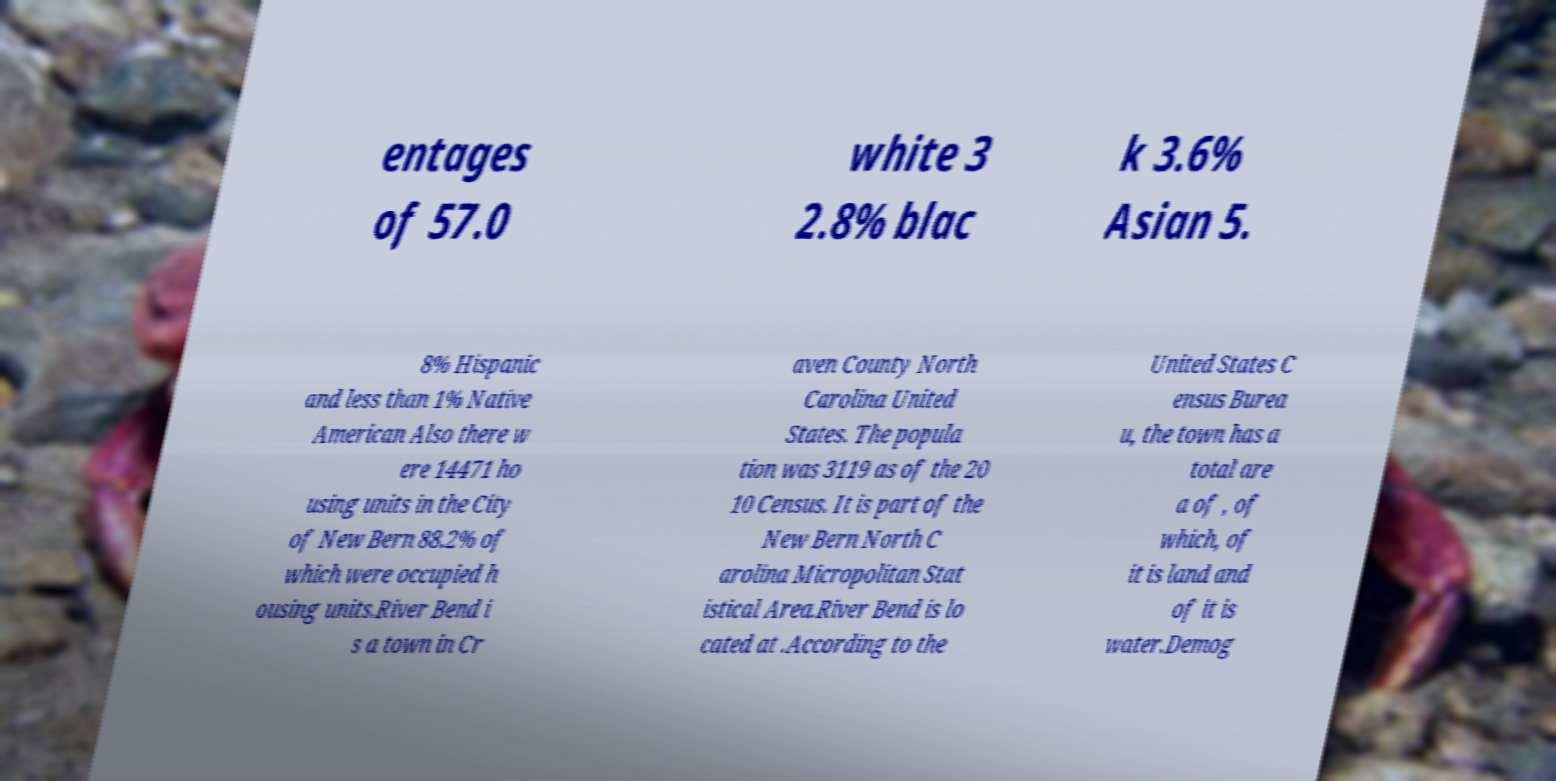There's text embedded in this image that I need extracted. Can you transcribe it verbatim? entages of 57.0 white 3 2.8% blac k 3.6% Asian 5. 8% Hispanic and less than 1% Native American Also there w ere 14471 ho using units in the City of New Bern 88.2% of which were occupied h ousing units.River Bend i s a town in Cr aven County North Carolina United States. The popula tion was 3119 as of the 20 10 Census. It is part of the New Bern North C arolina Micropolitan Stat istical Area.River Bend is lo cated at .According to the United States C ensus Burea u, the town has a total are a of , of which, of it is land and of it is water.Demog 